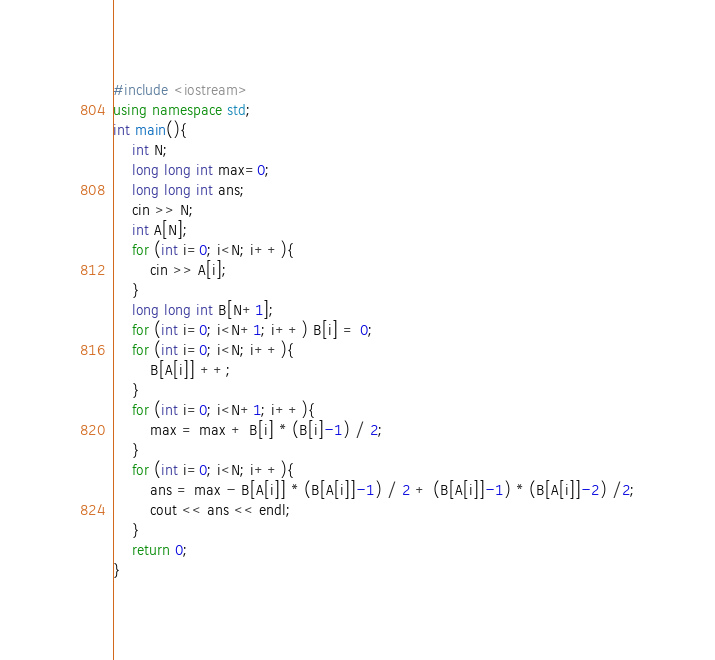Convert code to text. <code><loc_0><loc_0><loc_500><loc_500><_C++_>#include <iostream>
using namespace std;
int main(){
    int N;
    long long int max=0;
    long long int ans;
    cin >> N;
    int A[N];
    for (int i=0; i<N; i++){
        cin >> A[i];
    }
    long long int B[N+1];
    for (int i=0; i<N+1; i++) B[i] = 0;
    for (int i=0; i<N; i++){
        B[A[i]] ++;
    }
    for (int i=0; i<N+1; i++){
        max = max + B[i] * (B[i]-1) / 2;
    }
    for (int i=0; i<N; i++){
        ans = max - B[A[i]] * (B[A[i]]-1) / 2 + (B[A[i]]-1) * (B[A[i]]-2) /2;
        cout << ans << endl;
    }
    return 0;
}</code> 